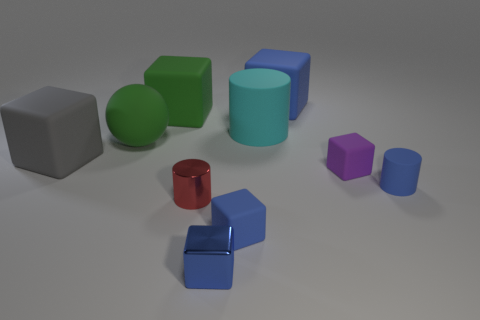Subtract all tiny metallic blocks. How many blocks are left? 5 Subtract 1 blocks. How many blocks are left? 5 Subtract all blue balls. Subtract all purple blocks. How many balls are left? 1 Subtract all green spheres. How many green cubes are left? 1 Subtract all big cyan metallic cylinders. Subtract all small blue cylinders. How many objects are left? 9 Add 9 gray objects. How many gray objects are left? 10 Add 5 tiny red shiny objects. How many tiny red shiny objects exist? 6 Subtract all cyan cylinders. How many cylinders are left? 2 Subtract 0 yellow balls. How many objects are left? 10 Subtract all cylinders. How many objects are left? 7 